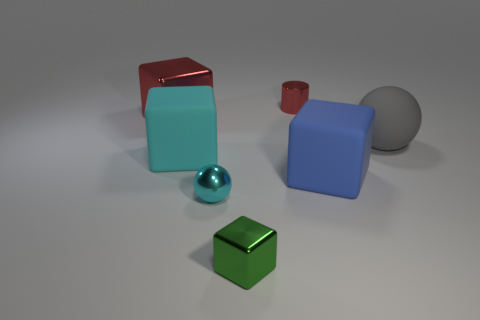Subtract all large red metallic blocks. How many blocks are left? 3 Add 1 gray rubber objects. How many objects exist? 8 Subtract all red blocks. How many blocks are left? 3 Subtract all cubes. How many objects are left? 3 Subtract 3 cubes. How many cubes are left? 1 Subtract 1 cyan cubes. How many objects are left? 6 Subtract all cyan cylinders. Subtract all brown blocks. How many cylinders are left? 1 Subtract all gray balls. How many gray cubes are left? 0 Subtract all blue matte objects. Subtract all small metallic things. How many objects are left? 3 Add 5 large spheres. How many large spheres are left? 6 